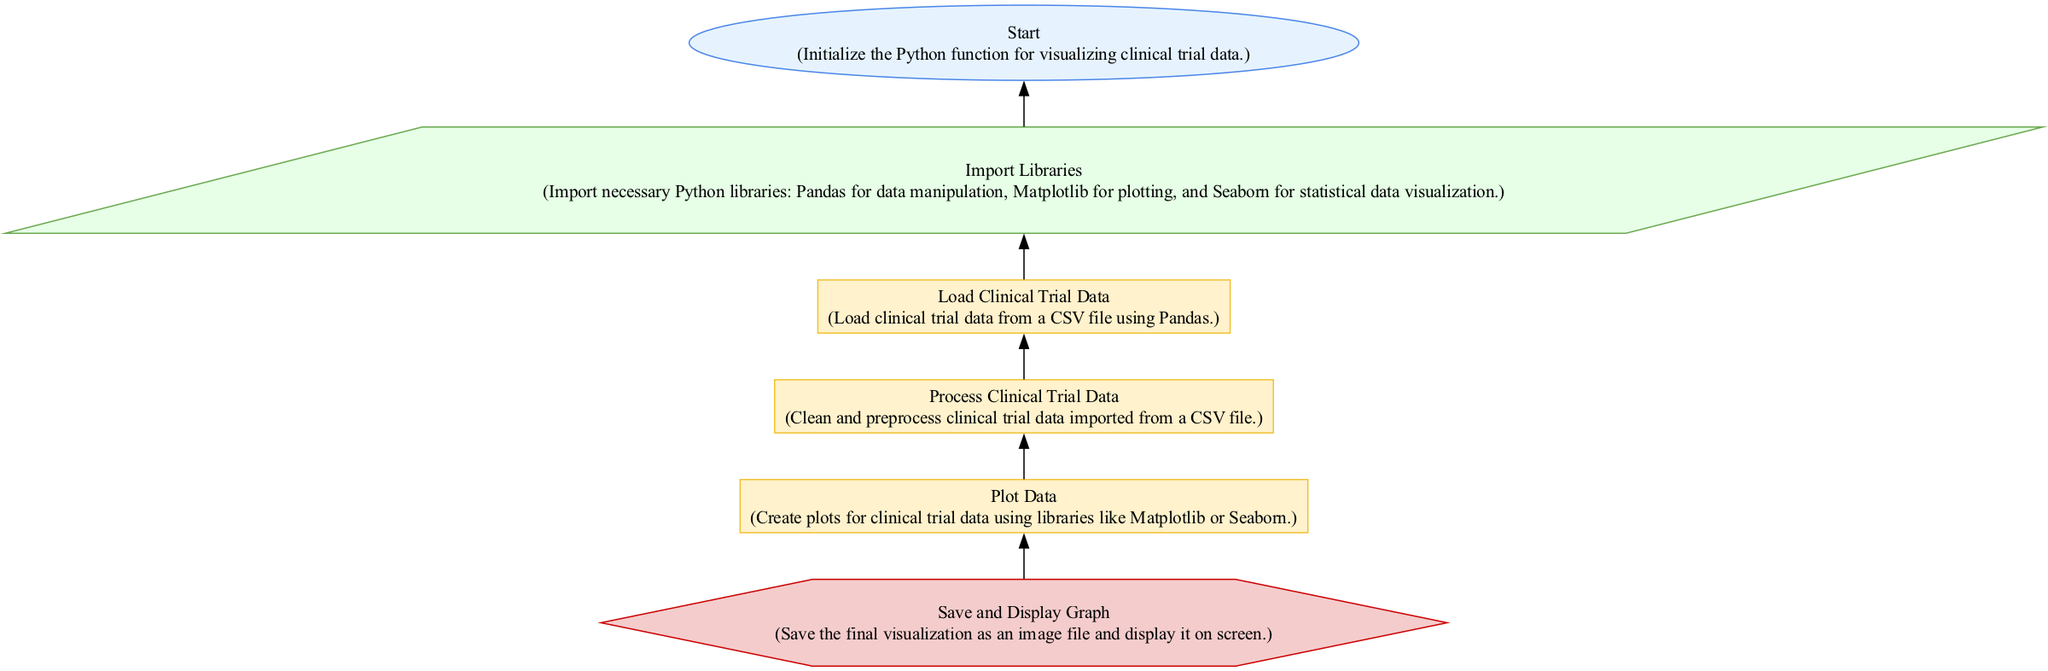what is the first step in the flowchart? The first step is labeled "Start," indicating the initialization of the function for visualizing clinical trial data. This node is the beginning of the flowchart.
Answer: Start how many processes are in the flowchart? There are three processes in the flowchart: "Load Clinical Trial Data," "Process Clinical Trial Data," and "Plot Data." Each represents a distinct step in handling the clinical trial data.
Answer: 3 what type of node follows the "Load Clinical Trial Data" node? The node that follows "Load Clinical Trial Data" is the "Process Clinical Trial Data" node. The flowchart indicates a direct progression from loading data to processing it.
Answer: Process Clinical Trial Data which library is specifically mentioned for statistical data visualization? The library specifically mentioned for statistical data visualization is Seaborn. This is included in the step that defines which libraries to import for the function.
Answer: Seaborn what is the final action taken in the diagram? The final action is "Save and Display Graph," where the graph is saved as an image file and displayed on the screen. This indicates the conclusion of the data visualization process.
Answer: Save and Display Graph what is the purpose of the "Process Clinical Trial Data" step? The purpose of this step is to clean and preprocess the clinical trial data that has been imported. This is crucial for ensuring the quality of the data before visualization.
Answer: Clean and preprocess which library is imported for data manipulation? The library imported for data manipulation is Pandas. This library is fundamental for handling and processing the clinical trial data in the function.
Answer: Pandas what shape is used for the "output" node in the diagram? The shape used for the "output" node, which is "Save and Display Graph," is a hexagon. This distinguishes it visually from other types of nodes in the flowchart.
Answer: Hexagon which step comes directly after the "Import Libraries" step? The step that comes directly after "Import Libraries" is "Load Clinical Trial Data." This represents the flow from importing necessary libraries to loading the actual data for analysis.
Answer: Load Clinical Trial Data 